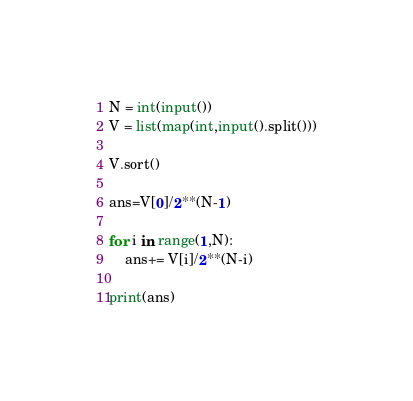Convert code to text. <code><loc_0><loc_0><loc_500><loc_500><_Python_>N = int(input())
V = list(map(int,input().split()))

V.sort()

ans=V[0]/2**(N-1)

for i in range(1,N):
    ans+= V[i]/2**(N-i)

print(ans)</code> 